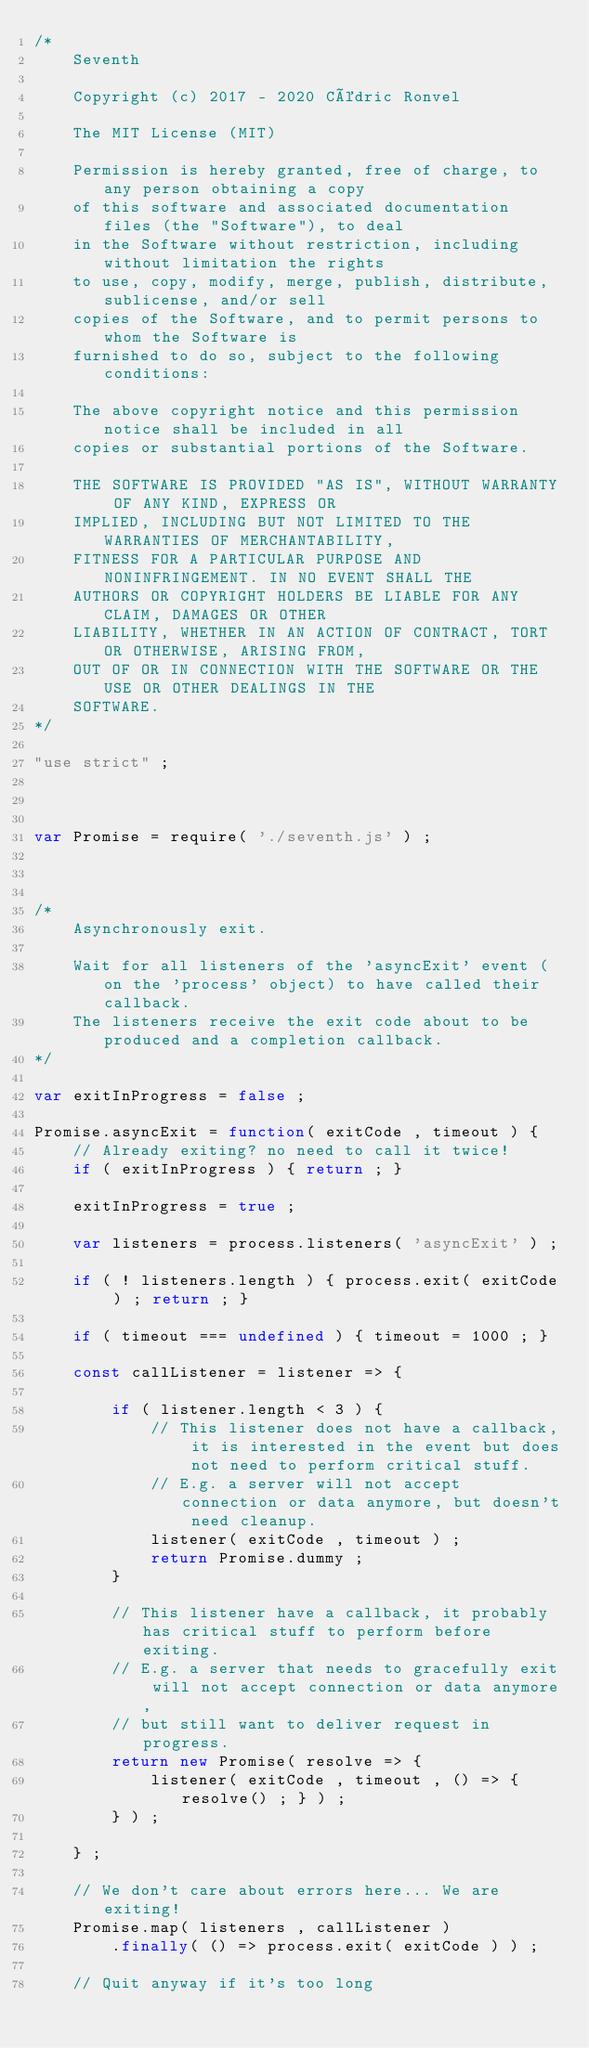Convert code to text. <code><loc_0><loc_0><loc_500><loc_500><_JavaScript_>/*
	Seventh

	Copyright (c) 2017 - 2020 Cédric Ronvel

	The MIT License (MIT)

	Permission is hereby granted, free of charge, to any person obtaining a copy
	of this software and associated documentation files (the "Software"), to deal
	in the Software without restriction, including without limitation the rights
	to use, copy, modify, merge, publish, distribute, sublicense, and/or sell
	copies of the Software, and to permit persons to whom the Software is
	furnished to do so, subject to the following conditions:

	The above copyright notice and this permission notice shall be included in all
	copies or substantial portions of the Software.

	THE SOFTWARE IS PROVIDED "AS IS", WITHOUT WARRANTY OF ANY KIND, EXPRESS OR
	IMPLIED, INCLUDING BUT NOT LIMITED TO THE WARRANTIES OF MERCHANTABILITY,
	FITNESS FOR A PARTICULAR PURPOSE AND NONINFRINGEMENT. IN NO EVENT SHALL THE
	AUTHORS OR COPYRIGHT HOLDERS BE LIABLE FOR ANY CLAIM, DAMAGES OR OTHER
	LIABILITY, WHETHER IN AN ACTION OF CONTRACT, TORT OR OTHERWISE, ARISING FROM,
	OUT OF OR IN CONNECTION WITH THE SOFTWARE OR THE USE OR OTHER DEALINGS IN THE
	SOFTWARE.
*/

"use strict" ;



var Promise = require( './seventh.js' ) ;



/*
	Asynchronously exit.

	Wait for all listeners of the 'asyncExit' event (on the 'process' object) to have called their callback.
	The listeners receive the exit code about to be produced and a completion callback.
*/

var exitInProgress = false ;

Promise.asyncExit = function( exitCode , timeout ) {
	// Already exiting? no need to call it twice!
	if ( exitInProgress ) { return ; }

	exitInProgress = true ;

	var listeners = process.listeners( 'asyncExit' ) ;

	if ( ! listeners.length ) { process.exit( exitCode ) ; return ; }

	if ( timeout === undefined ) { timeout = 1000 ; }

	const callListener = listener => {

		if ( listener.length < 3 ) {
			// This listener does not have a callback, it is interested in the event but does not need to perform critical stuff.
			// E.g. a server will not accept connection or data anymore, but doesn't need cleanup.
			listener( exitCode , timeout ) ;
			return Promise.dummy ;
		}

		// This listener have a callback, it probably has critical stuff to perform before exiting.
		// E.g. a server that needs to gracefully exit will not accept connection or data anymore,
		// but still want to deliver request in progress.
		return new Promise( resolve => {
			listener( exitCode , timeout , () => { resolve() ; } ) ;
		} ) ;

	} ;

	// We don't care about errors here... We are exiting!
	Promise.map( listeners , callListener )
		.finally( () => process.exit( exitCode ) ) ;

	// Quit anyway if it's too long</code> 